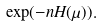Convert formula to latex. <formula><loc_0><loc_0><loc_500><loc_500>\exp ( - n H ( \mu ) ) .</formula> 